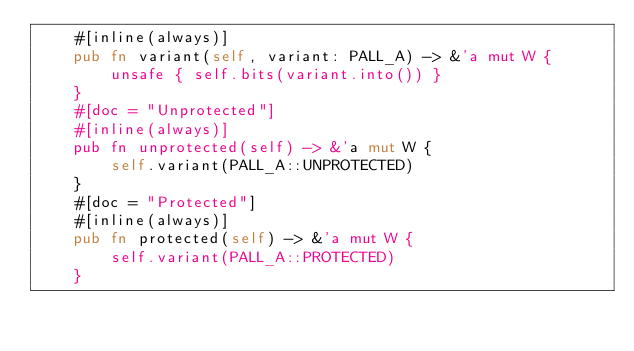<code> <loc_0><loc_0><loc_500><loc_500><_Rust_>    #[inline(always)]
    pub fn variant(self, variant: PALL_A) -> &'a mut W {
        unsafe { self.bits(variant.into()) }
    }
    #[doc = "Unprotected"]
    #[inline(always)]
    pub fn unprotected(self) -> &'a mut W {
        self.variant(PALL_A::UNPROTECTED)
    }
    #[doc = "Protected"]
    #[inline(always)]
    pub fn protected(self) -> &'a mut W {
        self.variant(PALL_A::PROTECTED)
    }</code> 